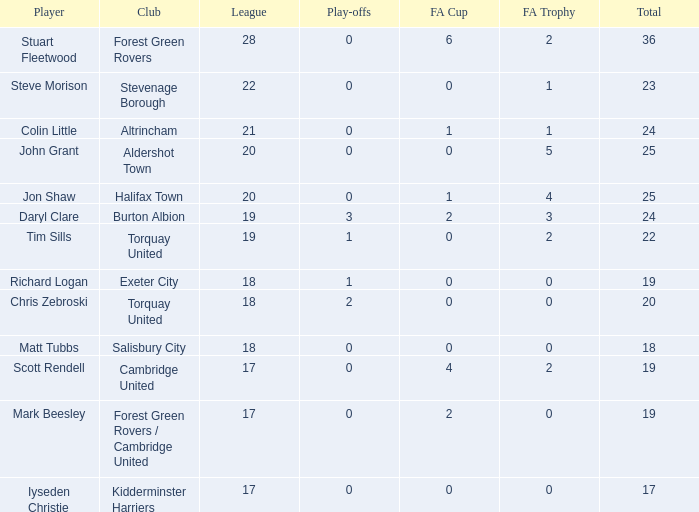What was the mean aggregate tim sills had as a player? 22.0. 